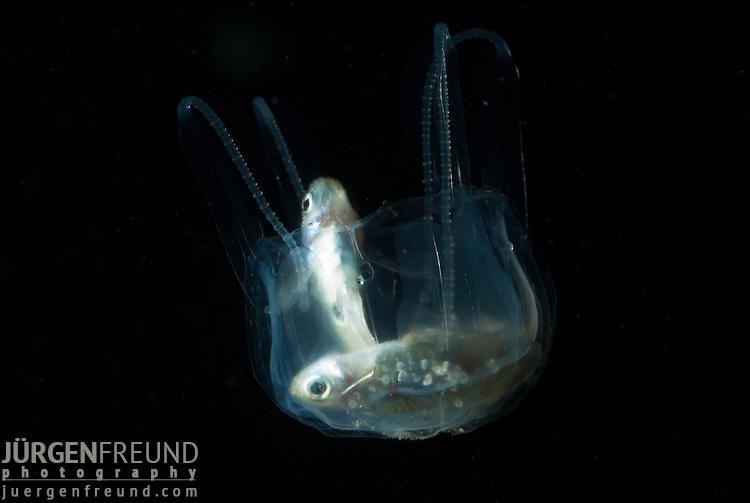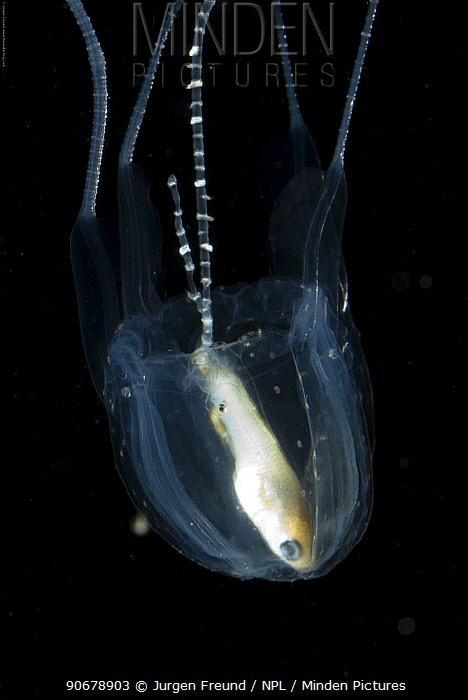The first image is the image on the left, the second image is the image on the right. For the images displayed, is the sentence "Both jellyfish are upside down." factually correct? Answer yes or no. Yes. The first image is the image on the left, the second image is the image on the right. Evaluate the accuracy of this statement regarding the images: "Two clear jellyfish are swimming downwards.". Is it true? Answer yes or no. Yes. 